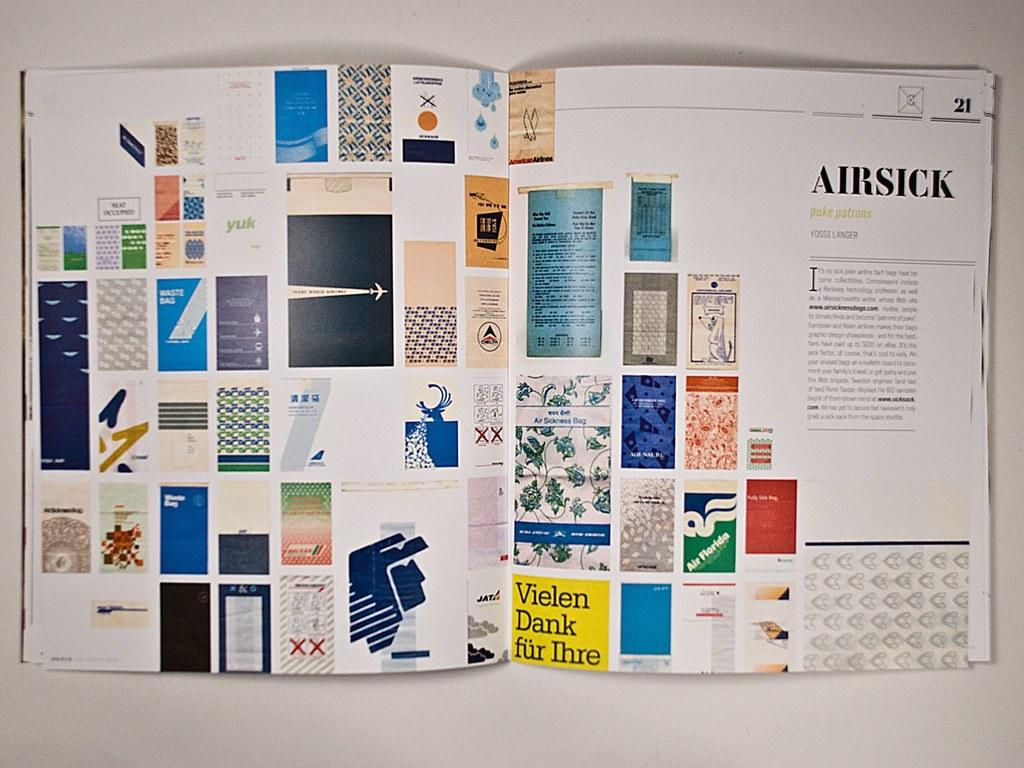Provide a one-sentence caption for the provided image. A magazine shows a display of bags and an article on being Airsick. 